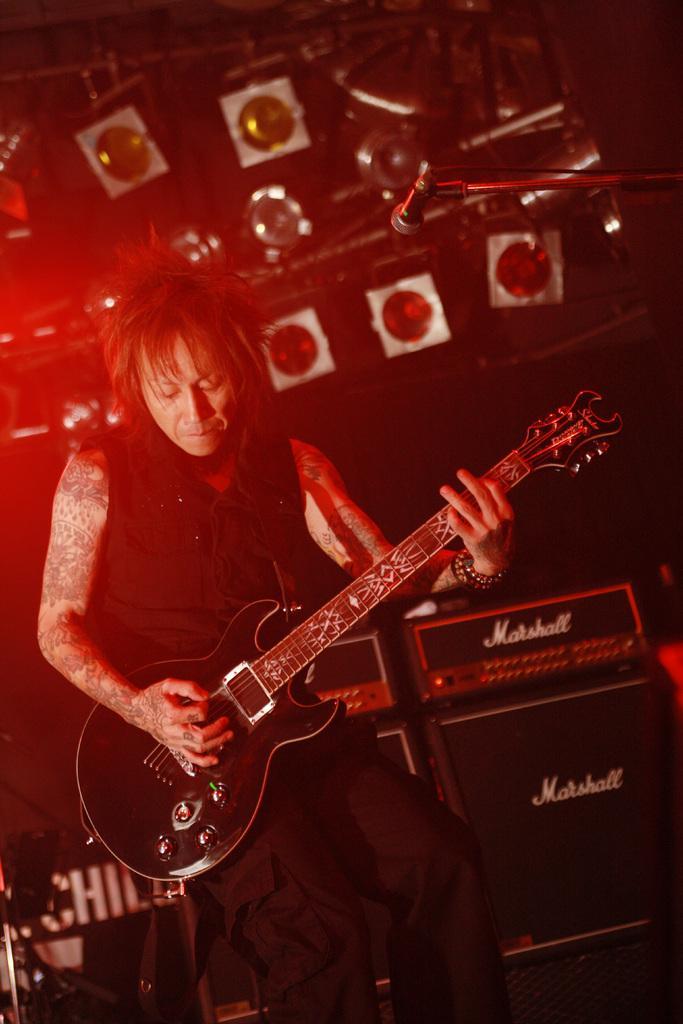How would you summarize this image in a sentence or two? In this image, there is a person in front of speakers wearing clothes and playing a guitar. There is a mic in the top right of the image. There are some lights at the top of the image. 